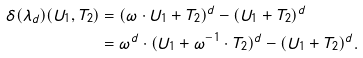<formula> <loc_0><loc_0><loc_500><loc_500>\delta ( \lambda _ { d } ) ( U _ { 1 } , T _ { 2 } ) & = ( \omega \cdot U _ { 1 } + T _ { 2 } ) ^ { d } - ( U _ { 1 } + T _ { 2 } ) ^ { d } \\ & = \omega ^ { d } \cdot ( U _ { 1 } + \omega ^ { - 1 } \cdot T _ { 2 } ) ^ { d } - ( U _ { 1 } + T _ { 2 } ) ^ { d } .</formula> 